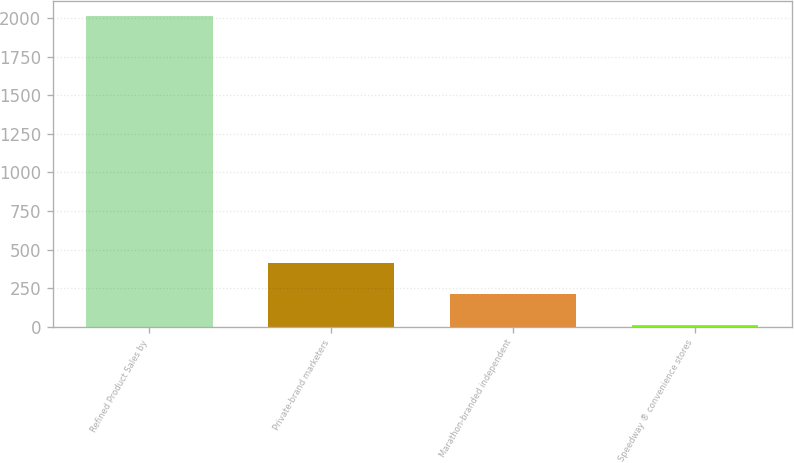<chart> <loc_0><loc_0><loc_500><loc_500><bar_chart><fcel>Refined Product Sales by<fcel>Private-brand marketers<fcel>Marathon-branded independent<fcel>Speedway ® convenience stores<nl><fcel>2014<fcel>412.4<fcel>212.2<fcel>12<nl></chart> 